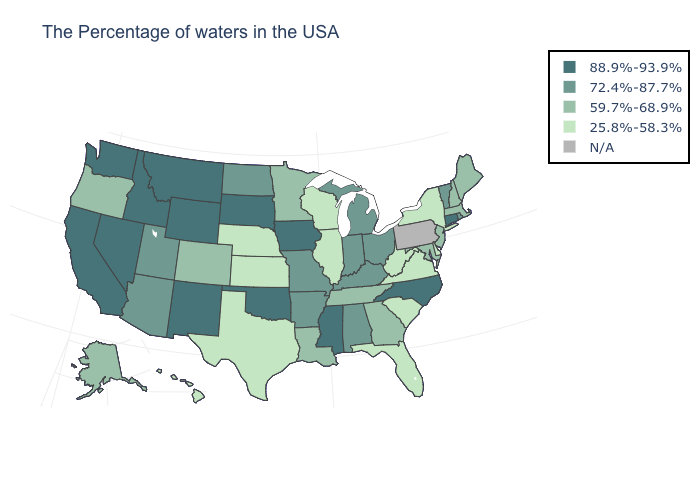Which states have the lowest value in the MidWest?
Keep it brief. Wisconsin, Illinois, Kansas, Nebraska. What is the value of New Hampshire?
Answer briefly. 59.7%-68.9%. Among the states that border Tennessee , which have the lowest value?
Quick response, please. Virginia. Does Montana have the highest value in the USA?
Give a very brief answer. Yes. Among the states that border Alabama , does Mississippi have the highest value?
Write a very short answer. Yes. What is the highest value in the South ?
Short answer required. 88.9%-93.9%. Name the states that have a value in the range 72.4%-87.7%?
Be succinct. Rhode Island, Vermont, Ohio, Michigan, Kentucky, Indiana, Alabama, Missouri, Arkansas, North Dakota, Utah, Arizona. Does the map have missing data?
Short answer required. Yes. What is the value of Rhode Island?
Quick response, please. 72.4%-87.7%. Does Arkansas have the lowest value in the South?
Be succinct. No. What is the highest value in the MidWest ?
Write a very short answer. 88.9%-93.9%. What is the value of New Mexico?
Keep it brief. 88.9%-93.9%. What is the value of Maryland?
Keep it brief. 59.7%-68.9%. What is the value of Rhode Island?
Concise answer only. 72.4%-87.7%. Among the states that border Wisconsin , does Illinois have the lowest value?
Give a very brief answer. Yes. 